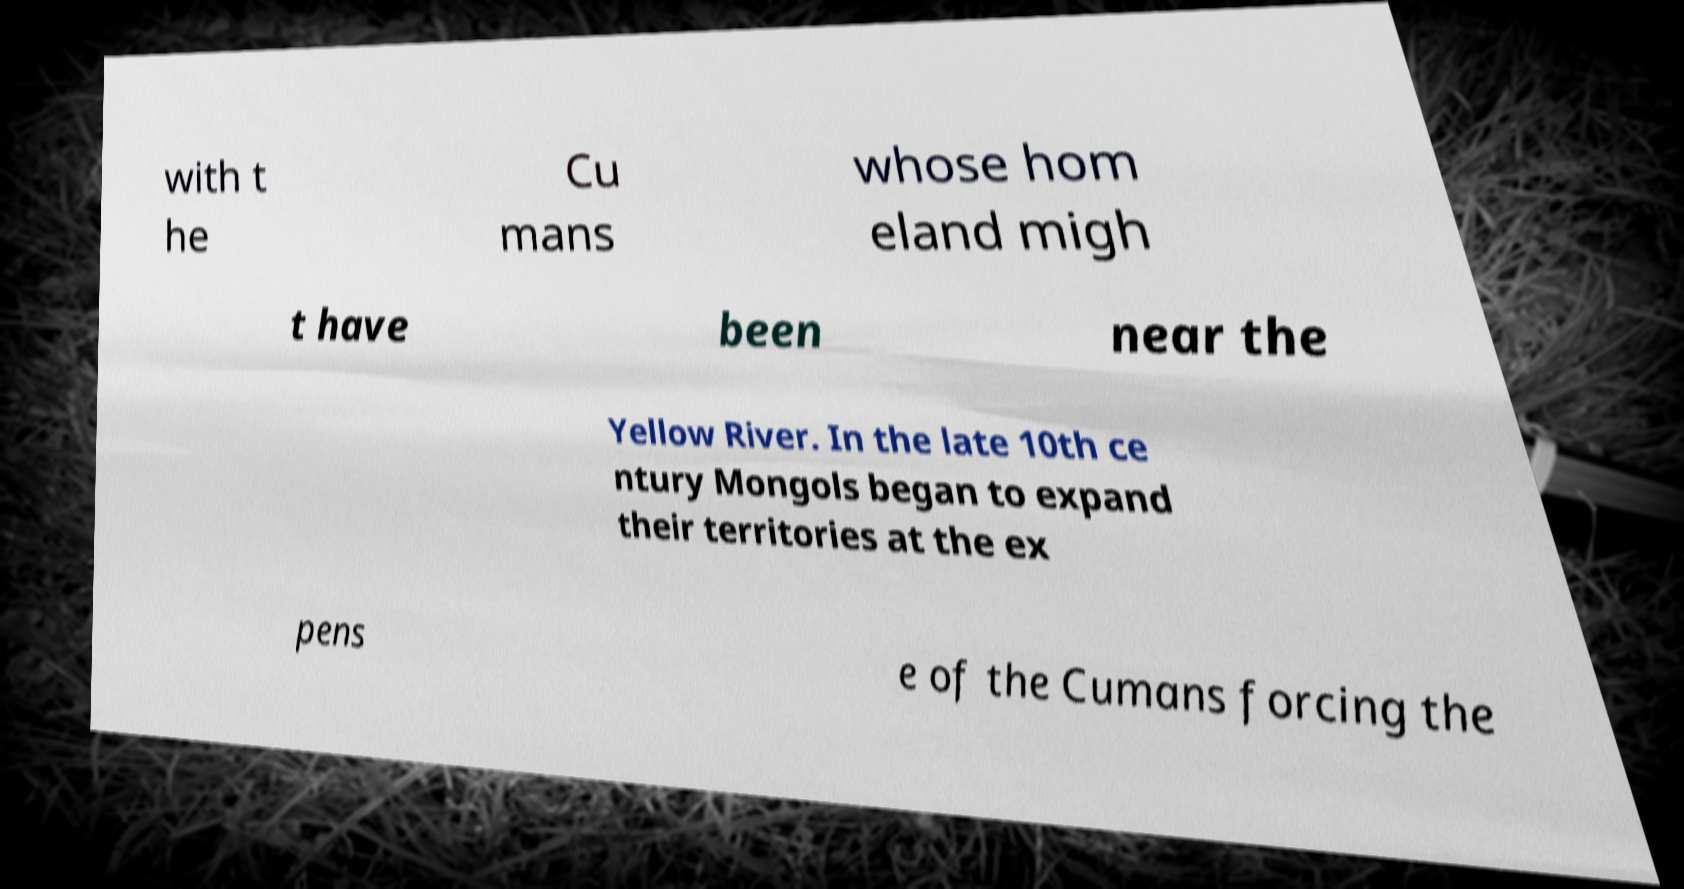Could you assist in decoding the text presented in this image and type it out clearly? with t he Cu mans whose hom eland migh t have been near the Yellow River. In the late 10th ce ntury Mongols began to expand their territories at the ex pens e of the Cumans forcing the 